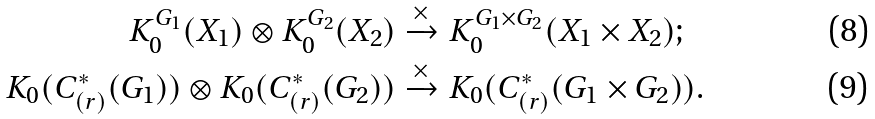Convert formula to latex. <formula><loc_0><loc_0><loc_500><loc_500>K _ { 0 } ^ { G _ { 1 } } ( X _ { 1 } ) \otimes K _ { 0 } ^ { G _ { 2 } } ( X _ { 2 } ) & \xrightarrow { \times } K _ { 0 } ^ { G _ { 1 } \times G _ { 2 } } ( X _ { 1 } \times X _ { 2 } ) ; \\ K _ { 0 } ( C ^ { * } _ { ( r ) } ( G _ { 1 } ) ) \otimes K _ { 0 } ( C ^ { * } _ { ( r ) } ( G _ { 2 } ) ) & \xrightarrow { \times } K _ { 0 } ( C ^ { * } _ { ( r ) } ( G _ { 1 } \times G _ { 2 } ) ) .</formula> 